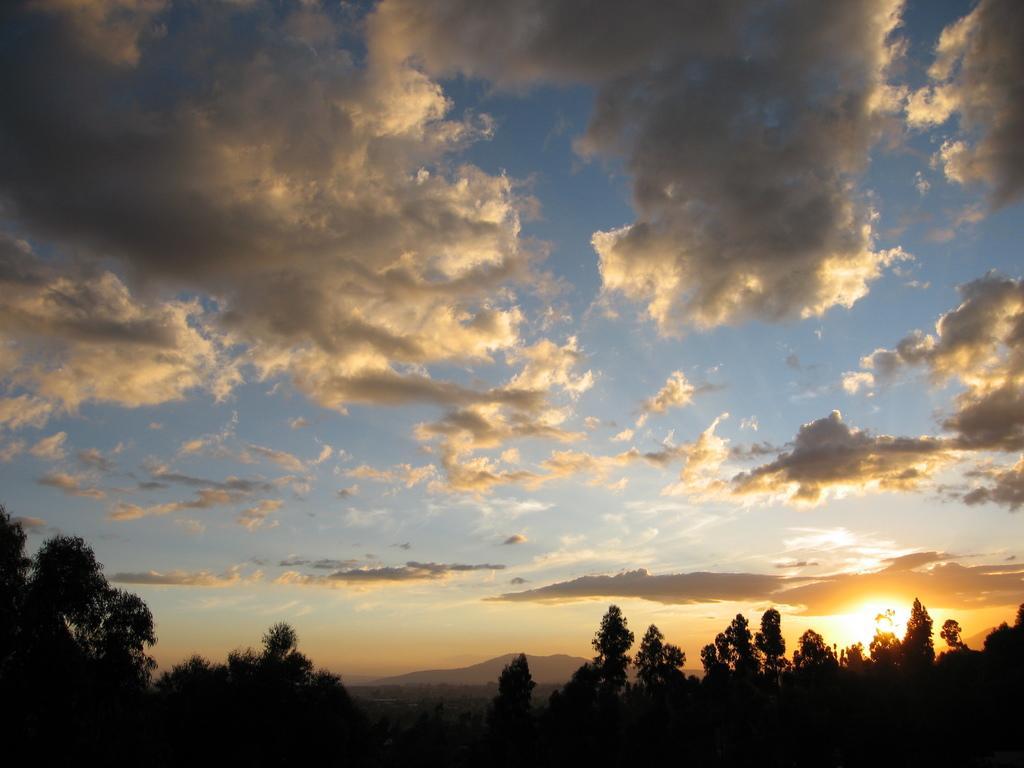In one or two sentences, can you explain what this image depicts? In this image there are trees at the bottom. At the top there is the sky with some clouds. On the right side bottom there is a sun. 